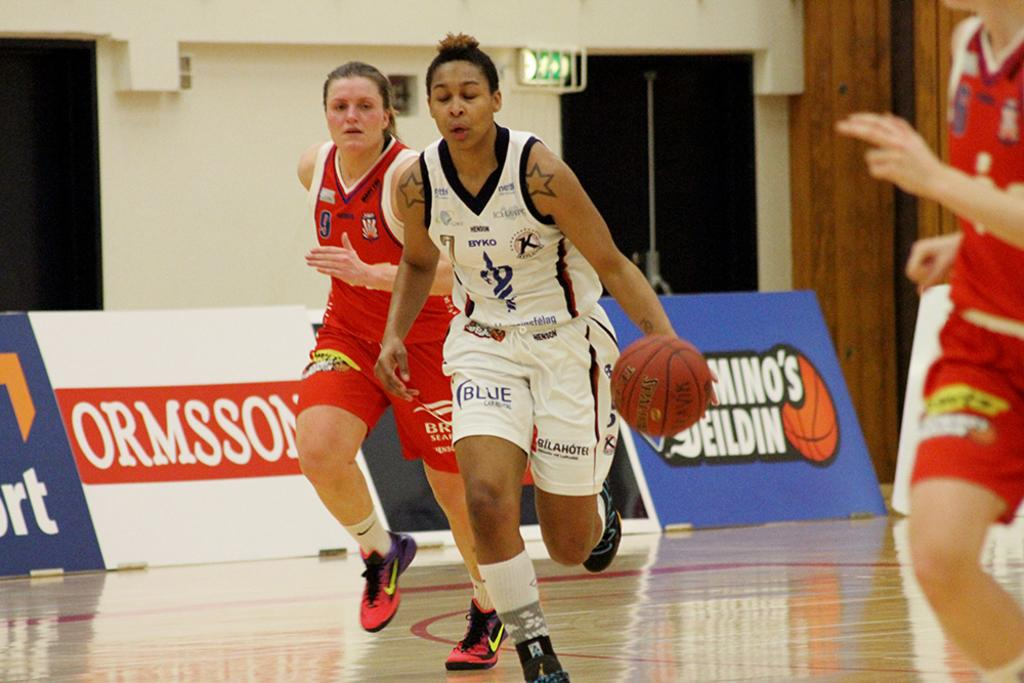<image>
Share a concise interpretation of the image provided. several basketball players with BYKO jerseys including players 9, 7, and 5 